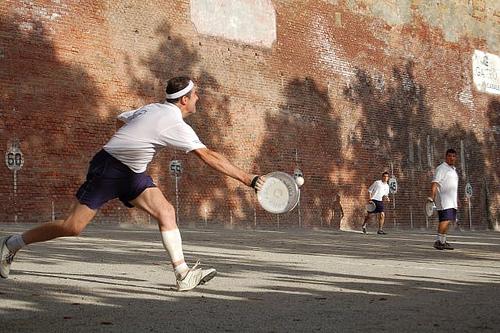Is this person trying to hit a ball?
Quick response, please. Yes. How many people are playing ball?
Answer briefly. 3. What is the person hitting the ball with?
Give a very brief answer. Frisbee. 